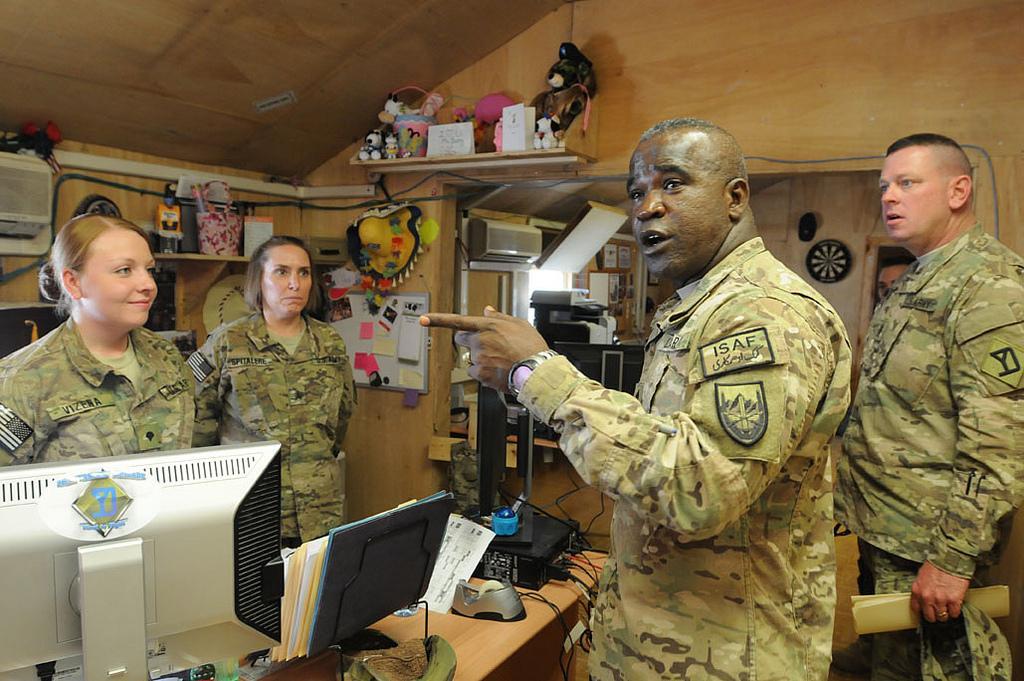Can you describe this image briefly? In this image there are persons standing, there is a person talking, there is a person holding an object, there are objects on the table, there is a desktop truncated towards the left of the image, there is a wall, there is a board on the wall, there are objects on the surface, there are objects truncated towards the left of the image, there are photo frames on the wall. 